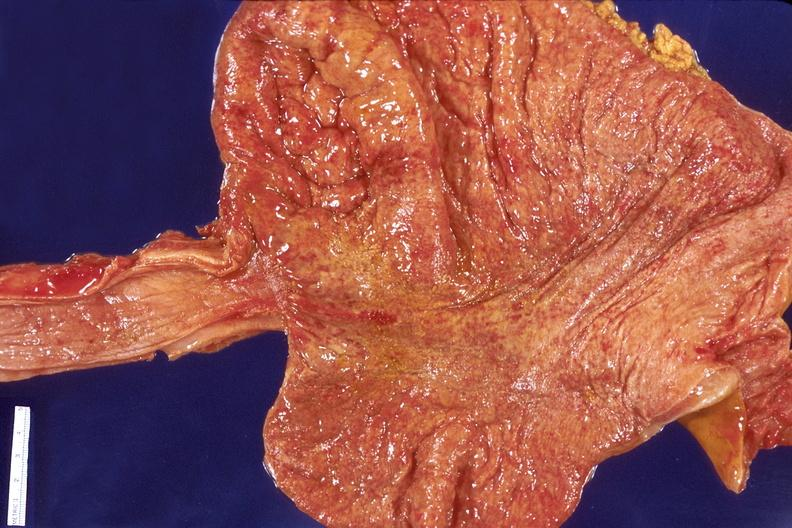what is present?
Answer the question using a single word or phrase. Gastrointestinal 